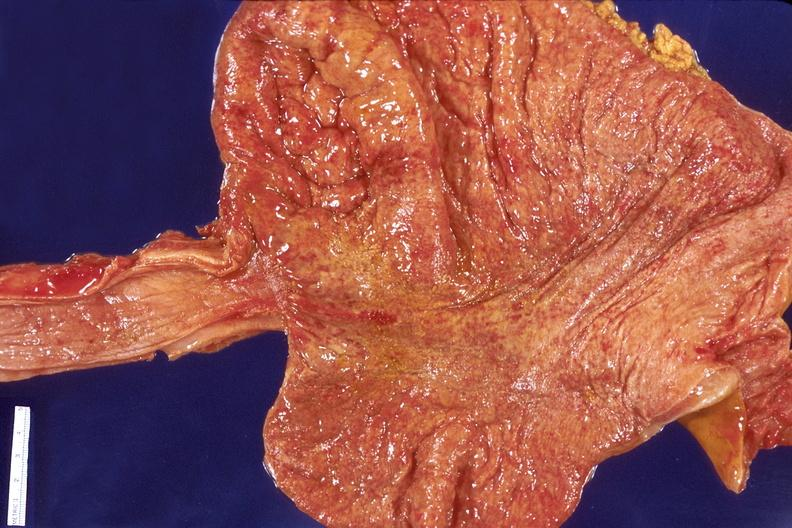what is present?
Answer the question using a single word or phrase. Gastrointestinal 